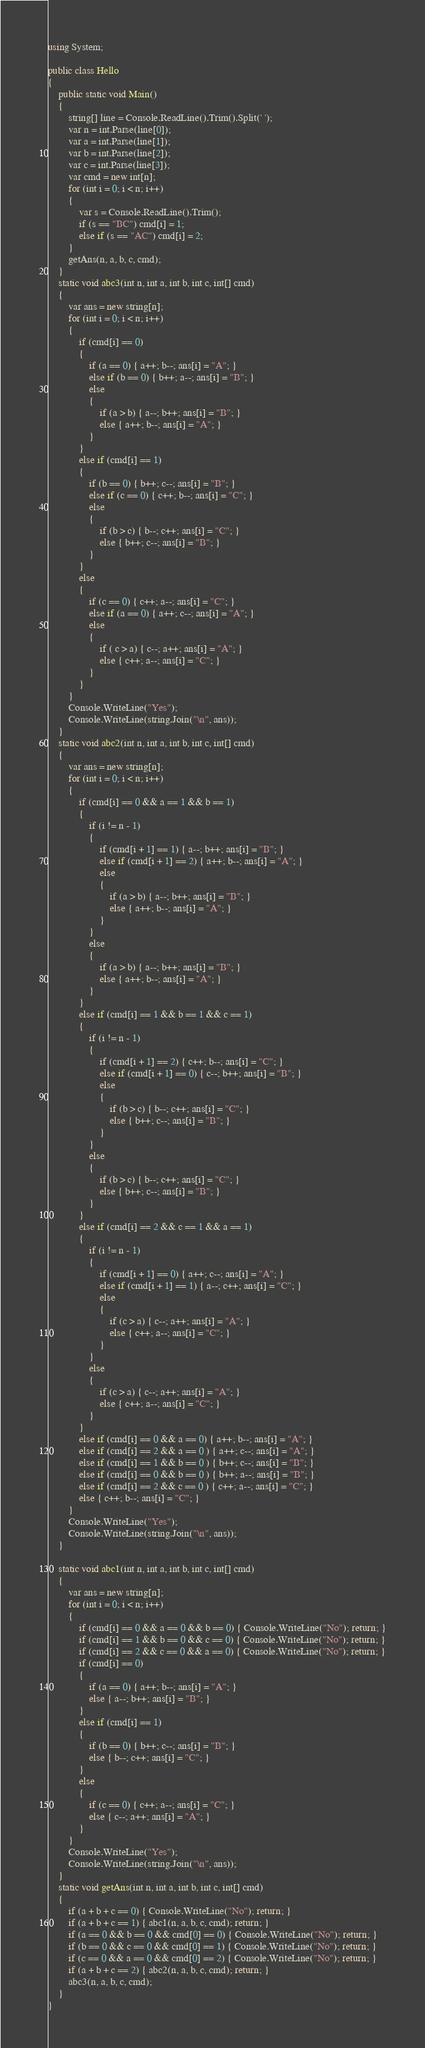<code> <loc_0><loc_0><loc_500><loc_500><_C#_>using System;

public class Hello
{
    public static void Main()
    {
        string[] line = Console.ReadLine().Trim().Split(' ');
        var n = int.Parse(line[0]);
        var a = int.Parse(line[1]);
        var b = int.Parse(line[2]);
        var c = int.Parse(line[3]);
        var cmd = new int[n];
        for (int i = 0; i < n; i++)
        {
            var s = Console.ReadLine().Trim();
            if (s == "BC") cmd[i] = 1;
            else if (s == "AC") cmd[i] = 2;
        }
        getAns(n, a, b, c, cmd);
    }
    static void abc3(int n, int a, int b, int c, int[] cmd)
    {
        var ans = new string[n];
        for (int i = 0; i < n; i++)
        {
            if (cmd[i] == 0)
            {
                if (a == 0) { a++; b--; ans[i] = "A"; }
                else if (b == 0) { b++; a--; ans[i] = "B"; }
                else
                {
                    if (a > b) { a--; b++; ans[i] = "B"; }
                    else { a++; b--; ans[i] = "A"; }
                }
            }
            else if (cmd[i] == 1)
            {
                if (b == 0) { b++; c--; ans[i] = "B"; }
                else if (c == 0) { c++; b--; ans[i] = "C"; }
                else
                {
                    if (b > c) { b--; c++; ans[i] = "C"; }
                    else { b++; c--; ans[i] = "B"; }
                }
            }
            else
            {
                if (c == 0) { c++; a--; ans[i] = "C"; }
                else if (a == 0) { a++; c--; ans[i] = "A"; }
                else
                {
                    if ( c > a) { c--; a++; ans[i] = "A"; }
                    else { c++; a--; ans[i] = "C"; }
                }
            }
        }
        Console.WriteLine("Yes");
        Console.WriteLine(string.Join("\n", ans));
    }
    static void abc2(int n, int a, int b, int c, int[] cmd)
    {
        var ans = new string[n];
        for (int i = 0; i < n; i++)
        {
            if (cmd[i] == 0 && a == 1 && b == 1)
            {
                if (i != n - 1)
                {
                    if (cmd[i + 1] == 1) { a--; b++; ans[i] = "B"; }
                    else if (cmd[i + 1] == 2) { a++; b--; ans[i] = "A"; }
                    else
                    {
                        if (a > b) { a--; b++; ans[i] = "B"; }
                        else { a++; b--; ans[i] = "A"; }
                    }
                }
                else
                {
                    if (a > b) { a--; b++; ans[i] = "B"; }
                    else { a++; b--; ans[i] = "A"; }
                }
            }
            else if (cmd[i] == 1 && b == 1 && c == 1)
            {
                if (i != n - 1)
                {
                    if (cmd[i + 1] == 2) { c++; b--; ans[i] = "C"; }
                    else if (cmd[i + 1] == 0) { c--; b++; ans[i] = "B"; }
                    else
                    {
                        if (b > c) { b--; c++; ans[i] = "C"; }
                        else { b++; c--; ans[i] = "B"; }
                    }
                }
                else
                {
                    if (b > c) { b--; c++; ans[i] = "C"; }
                    else { b++; c--; ans[i] = "B"; }
                }
            }
            else if (cmd[i] == 2 && c == 1 && a == 1)
            {
                if (i != n - 1)
                {
                    if (cmd[i + 1] == 0) { a++; c--; ans[i] = "A"; }
                    else if (cmd[i + 1] == 1) { a--; c++; ans[i] = "C"; }
                    else
                    {
                        if (c > a) { c--; a++; ans[i] = "A"; }
                        else { c++; a--; ans[i] = "C"; }
                    }
                }
                else
                {
                    if (c > a) { c--; a++; ans[i] = "A"; }
                    else { c++; a--; ans[i] = "C"; }
                }
            }
            else if (cmd[i] == 0 && a == 0) { a++; b--; ans[i] = "A"; }
            else if (cmd[i] == 2 && a == 0 ) { a++; c--; ans[i] = "A"; }
            else if (cmd[i] == 1 && b == 0 ) { b++; c--; ans[i] = "B"; }
            else if (cmd[i] == 0 && b == 0 ) { b++; a--; ans[i] = "B"; }
            else if (cmd[i] == 2 && c == 0 ) { c++; a--; ans[i] = "C"; }
            else { c++; b--; ans[i] = "C"; }
        }
        Console.WriteLine("Yes");
        Console.WriteLine(string.Join("\n", ans));
    }

    static void abc1(int n, int a, int b, int c, int[] cmd)
    {
        var ans = new string[n];
        for (int i = 0; i < n; i++)
        {
            if (cmd[i] == 0 && a == 0 && b == 0) { Console.WriteLine("No"); return; }
            if (cmd[i] == 1 && b == 0 && c == 0) { Console.WriteLine("No"); return; }
            if (cmd[i] == 2 && c == 0 && a == 0) { Console.WriteLine("No"); return; }
            if (cmd[i] == 0)
            {
                if (a == 0) { a++; b--; ans[i] = "A"; }
                else { a--; b++; ans[i] = "B"; }
            }
            else if (cmd[i] == 1)
            {
                if (b == 0) { b++; c--; ans[i] = "B"; }
                else { b--; c++; ans[i] = "C"; }
            }
            else
            {
                if (c == 0) { c++; a--; ans[i] = "C"; }
                else { c--; a++; ans[i] = "A"; }
            }
        }
        Console.WriteLine("Yes");
        Console.WriteLine(string.Join("\n", ans));
    }
    static void getAns(int n, int a, int b, int c, int[] cmd)
    {
        if (a + b + c == 0) { Console.WriteLine("No"); return; }
        if (a + b + c == 1) { abc1(n, a, b, c, cmd); return; }
        if (a == 0 && b == 0 && cmd[0] == 0) { Console.WriteLine("No"); return; }
        if (b == 0 && c == 0 && cmd[0] == 1) { Console.WriteLine("No"); return; }
        if (c == 0 && a == 0 && cmd[0] == 2) { Console.WriteLine("No"); return; }
        if (a + b + c == 2) { abc2(n, a, b, c, cmd); return; }
        abc3(n, a, b, c, cmd);
    }
}
</code> 